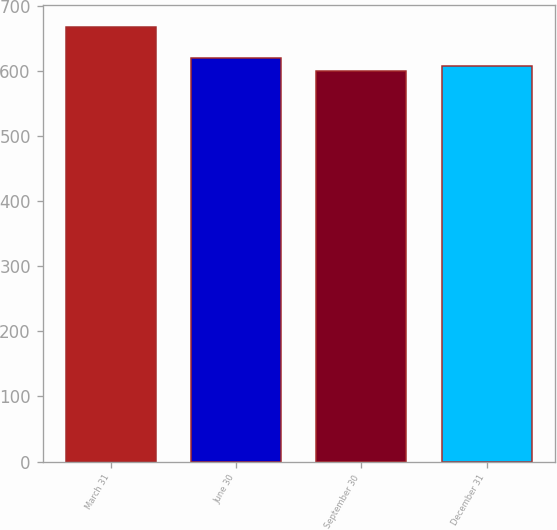Convert chart to OTSL. <chart><loc_0><loc_0><loc_500><loc_500><bar_chart><fcel>March 31<fcel>June 30<fcel>September 30<fcel>December 31<nl><fcel>668<fcel>620<fcel>601<fcel>607.7<nl></chart> 